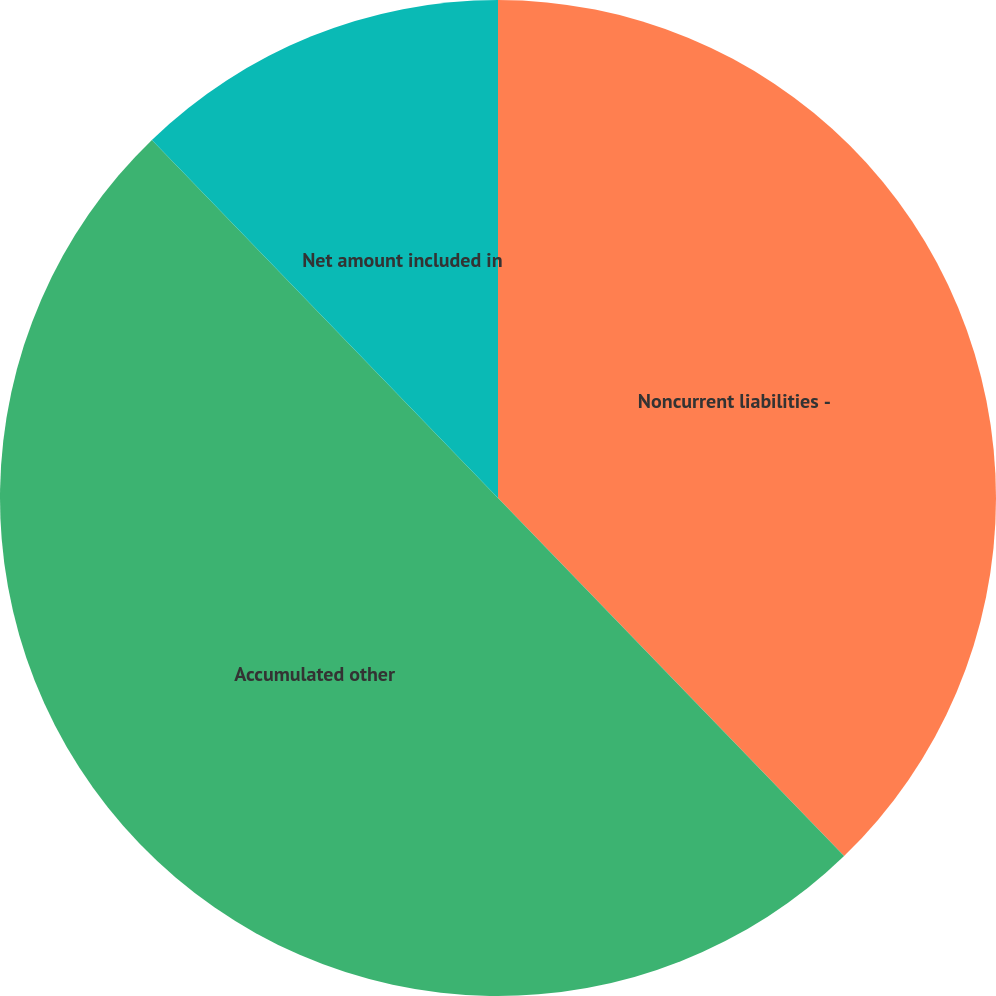<chart> <loc_0><loc_0><loc_500><loc_500><pie_chart><fcel>Noncurrent liabilities -<fcel>Accumulated other<fcel>Net amount included in<nl><fcel>37.77%<fcel>50.0%<fcel>12.23%<nl></chart> 